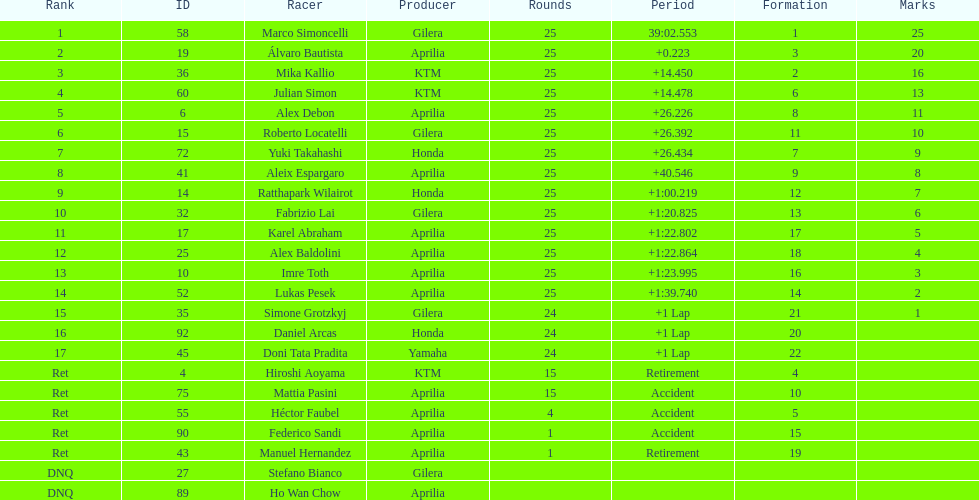The next rider from italy aside from winner marco simoncelli was Roberto Locatelli. Would you mind parsing the complete table? {'header': ['Rank', 'ID', 'Racer', 'Producer', 'Rounds', 'Period', 'Formation', 'Marks'], 'rows': [['1', '58', 'Marco Simoncelli', 'Gilera', '25', '39:02.553', '1', '25'], ['2', '19', 'Álvaro Bautista', 'Aprilia', '25', '+0.223', '3', '20'], ['3', '36', 'Mika Kallio', 'KTM', '25', '+14.450', '2', '16'], ['4', '60', 'Julian Simon', 'KTM', '25', '+14.478', '6', '13'], ['5', '6', 'Alex Debon', 'Aprilia', '25', '+26.226', '8', '11'], ['6', '15', 'Roberto Locatelli', 'Gilera', '25', '+26.392', '11', '10'], ['7', '72', 'Yuki Takahashi', 'Honda', '25', '+26.434', '7', '9'], ['8', '41', 'Aleix Espargaro', 'Aprilia', '25', '+40.546', '9', '8'], ['9', '14', 'Ratthapark Wilairot', 'Honda', '25', '+1:00.219', '12', '7'], ['10', '32', 'Fabrizio Lai', 'Gilera', '25', '+1:20.825', '13', '6'], ['11', '17', 'Karel Abraham', 'Aprilia', '25', '+1:22.802', '17', '5'], ['12', '25', 'Alex Baldolini', 'Aprilia', '25', '+1:22.864', '18', '4'], ['13', '10', 'Imre Toth', 'Aprilia', '25', '+1:23.995', '16', '3'], ['14', '52', 'Lukas Pesek', 'Aprilia', '25', '+1:39.740', '14', '2'], ['15', '35', 'Simone Grotzkyj', 'Gilera', '24', '+1 Lap', '21', '1'], ['16', '92', 'Daniel Arcas', 'Honda', '24', '+1 Lap', '20', ''], ['17', '45', 'Doni Tata Pradita', 'Yamaha', '24', '+1 Lap', '22', ''], ['Ret', '4', 'Hiroshi Aoyama', 'KTM', '15', 'Retirement', '4', ''], ['Ret', '75', 'Mattia Pasini', 'Aprilia', '15', 'Accident', '10', ''], ['Ret', '55', 'Héctor Faubel', 'Aprilia', '4', 'Accident', '5', ''], ['Ret', '90', 'Federico Sandi', 'Aprilia', '1', 'Accident', '15', ''], ['Ret', '43', 'Manuel Hernandez', 'Aprilia', '1', 'Retirement', '19', ''], ['DNQ', '27', 'Stefano Bianco', 'Gilera', '', '', '', ''], ['DNQ', '89', 'Ho Wan Chow', 'Aprilia', '', '', '', '']]} 